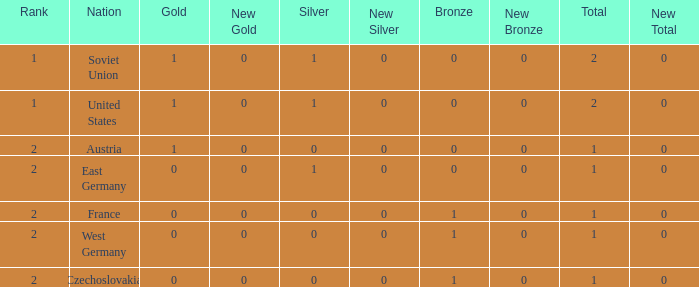What is the total number of bronze medals of West Germany, which is ranked 2 and has less than 1 total medals? 0.0. 